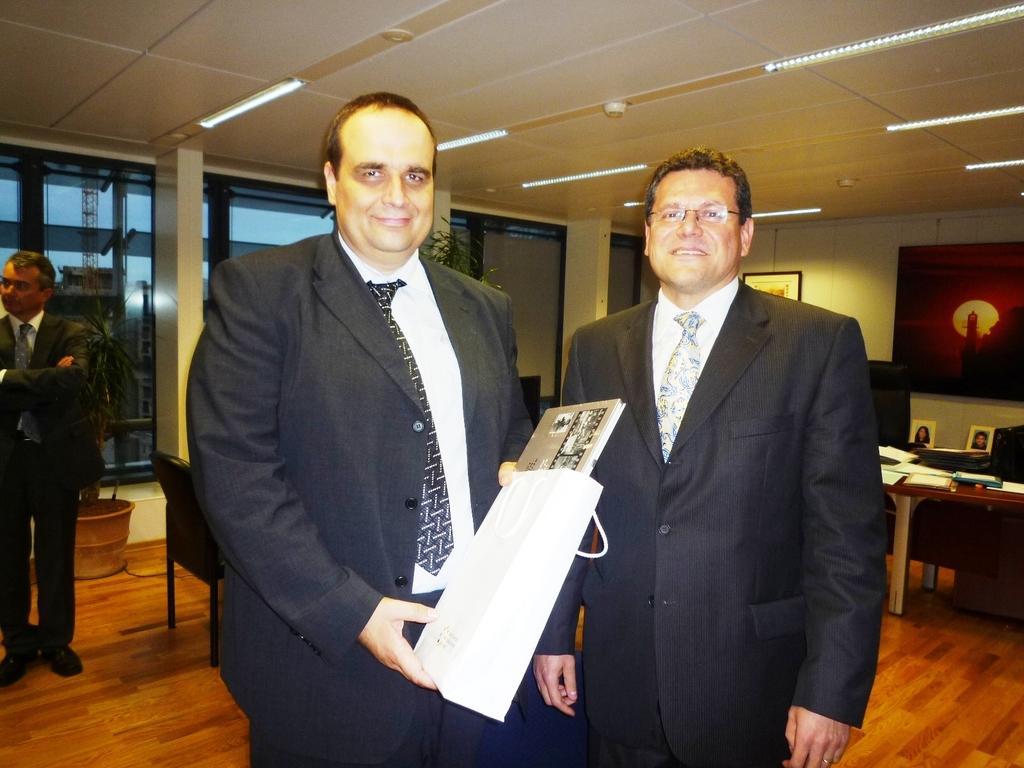Please provide a concise description of this image. There are 2 men, a person is holding a cover behind them there are windows,frames on the wall,table,chairs and a house plant. 